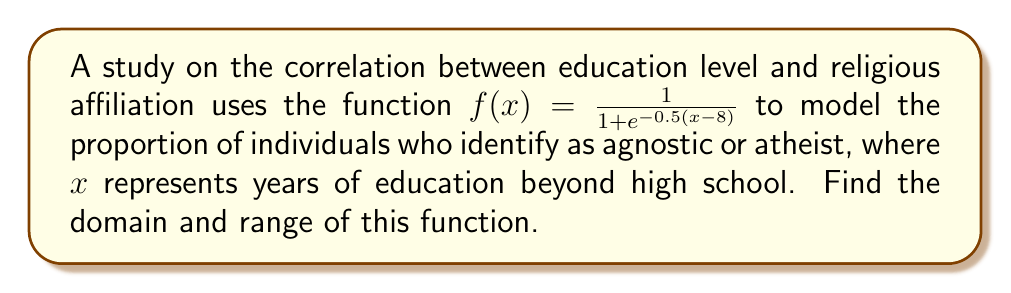Help me with this question. To find the domain and range of this function, we need to analyze its structure:

1. Domain:
   The function $f(x) = \frac{1}{1 + e^{-0.5(x-8)}}$ is a logistic function.
   - The denominator $1 + e^{-0.5(x-8)}$ is always positive for any real number $x$.
   - There are no restrictions on $x$ in this function.
   Therefore, the domain is all real numbers: $(-\infty, \infty)$.

2. Range:
   To find the range, let's analyze the behavior of the function:
   
   a) As $x \to -\infty$:
      $e^{-0.5(x-8)} \to \infty$, so $f(x) \to \frac{1}{\infty} = 0$
   
   b) As $x \to \infty$:
      $e^{-0.5(x-8)} \to 0$, so $f(x) \to \frac{1}{1+0} = 1$
   
   c) For any finite $x$:
      $e^{-0.5(x-8)}$ is always positive, so $1 + e^{-0.5(x-8)} > 1$
      Therefore, $0 < f(x) < 1$ for all $x$

   The function approaches but never actually reaches 0 or 1.
   Thus, the range is $(0, 1)$, which means all numbers greater than 0 and less than 1.
Answer: Domain: $(-\infty, \infty)$
Range: $(0, 1)$ 